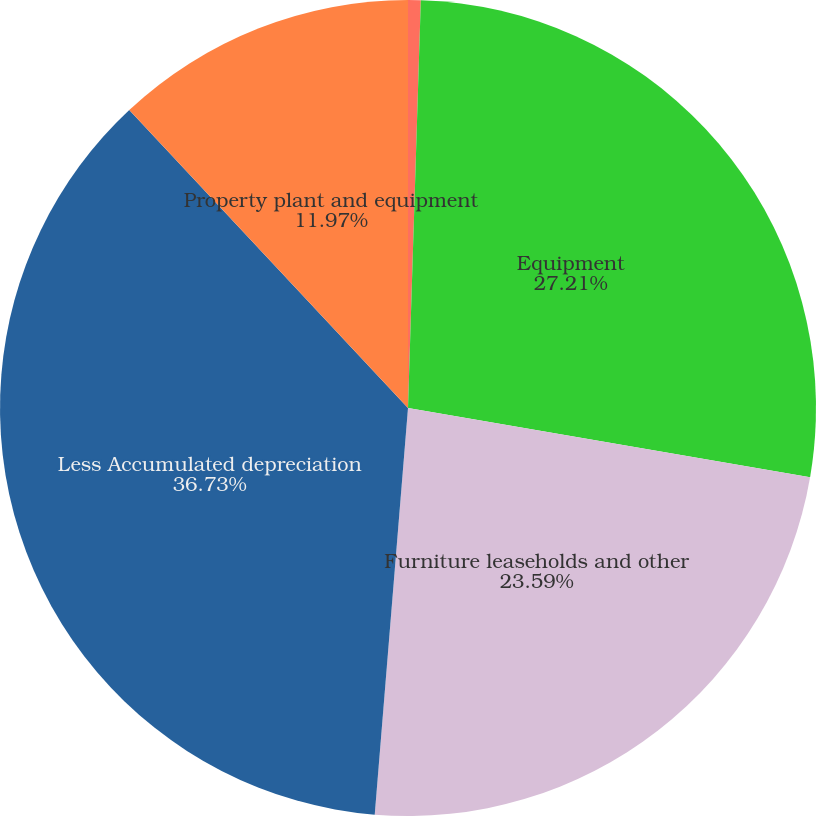Convert chart to OTSL. <chart><loc_0><loc_0><loc_500><loc_500><pie_chart><fcel>Land and buildings<fcel>Equipment<fcel>Furniture leaseholds and other<fcel>Less Accumulated depreciation<fcel>Property plant and equipment<nl><fcel>0.5%<fcel>27.21%<fcel>23.59%<fcel>36.73%<fcel>11.97%<nl></chart> 